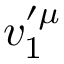<formula> <loc_0><loc_0><loc_500><loc_500>v _ { 1 } ^ { \prime \mu }</formula> 